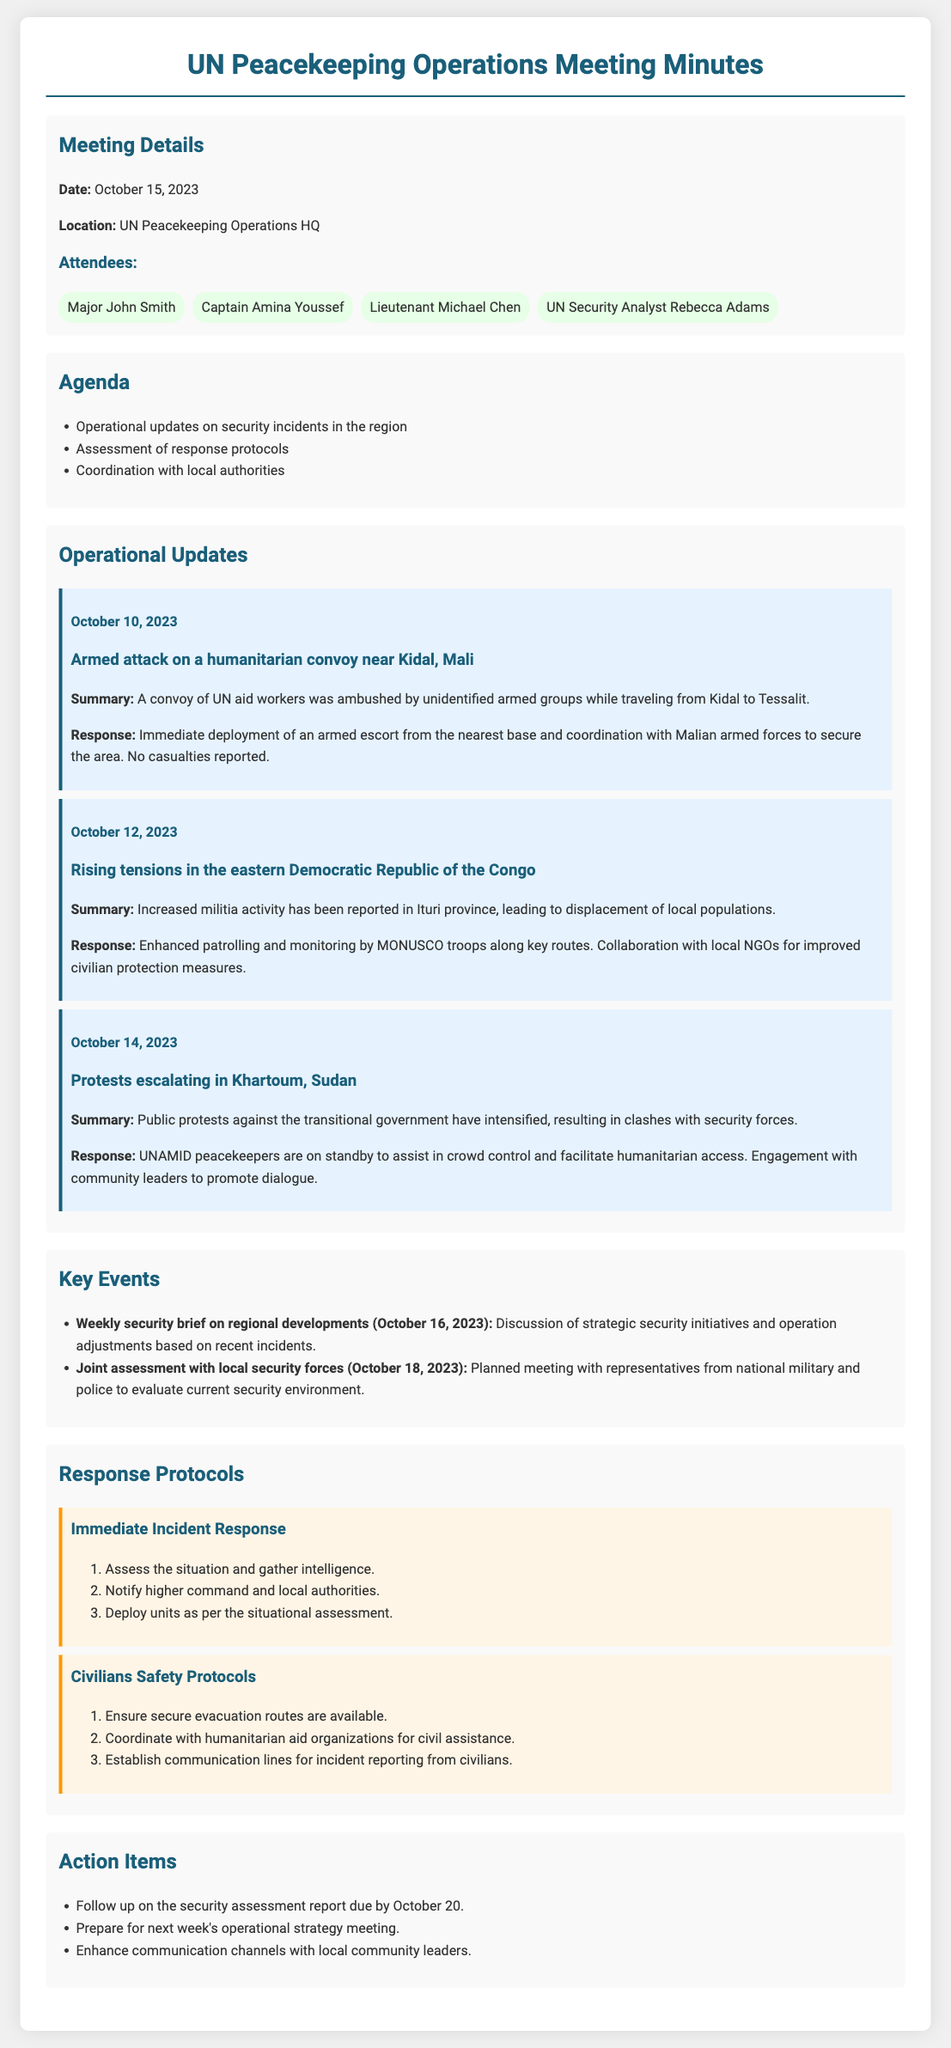what is the date of the meeting? The date of the meeting is provided at the beginning of the document under Meeting Details.
Answer: October 15, 2023 who was attacked in the incident on October 10, 2023? The incident on October 10, 2023, involved a convoy of UN aid workers.
Answer: UN aid workers what response was taken for the armed attack on October 10, 2023? The response included immediate deployment of an armed escort and coordination with Malian armed forces, which are detailed in the Operational Updates section.
Answer: Immediate deployment of an armed escort how many attendees were present at the meeting? The number of attendees is listed in the Meeting Details section where names are provided.
Answer: 4 what were the planned key events discussed for October 16, 2023? The key events include a weekly security brief on regional developments, as mentioned in the Key Events section.
Answer: Weekly security brief on regional developments what is the first step in the Immediate Incident Response protocol? The Immediate Incident Response protocol outlines specific steps starting with situation assessment.
Answer: Assess the situation and gather intelligence which country's province reported rising militia activity? The document specifies rising militia activity in Ituri province, which is located in the Democratic Republic of the Congo.
Answer: Democratic Republic of the Congo what action is due by October 20, 2023? The Action Items section states that there is a follow-up on a security assessment report due by that date.
Answer: Follow up on the security assessment report 